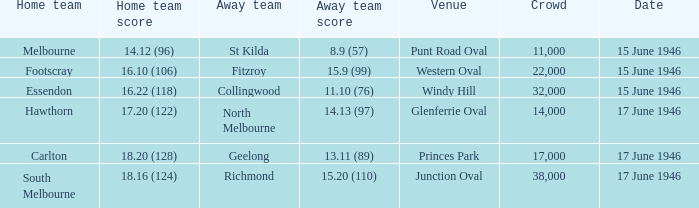On which date was a match conducted at windy hill? 15 June 1946. 